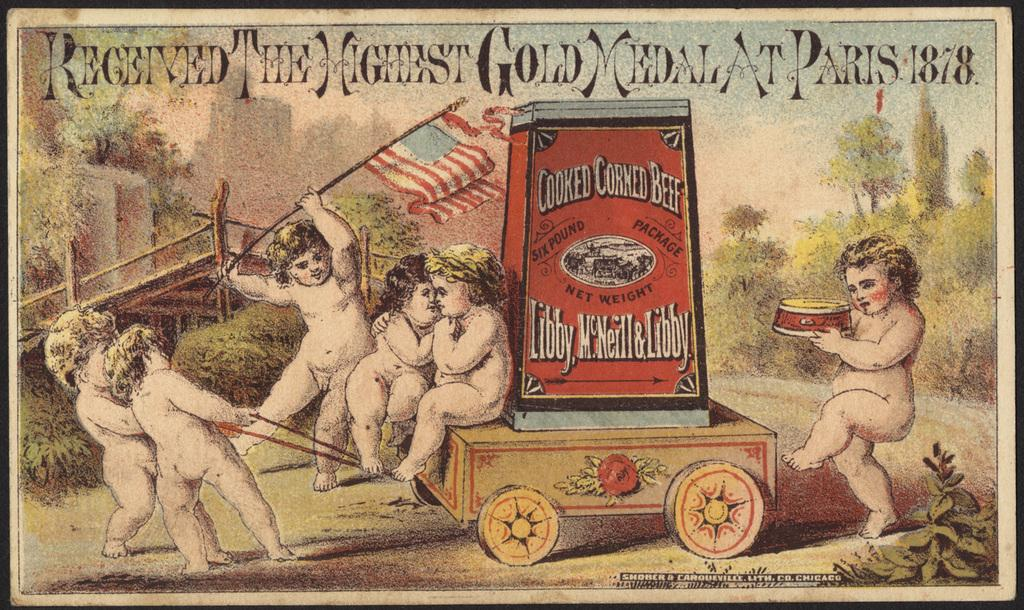<image>
Provide a brief description of the given image. A postcard that says Received the highest gold medal at Paris 1878 is displayed. 